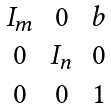Convert formula to latex. <formula><loc_0><loc_0><loc_500><loc_500>\begin{matrix} I _ { m } & 0 & b \\ 0 & I _ { n } & 0 \\ 0 & 0 & 1 \\ \end{matrix}</formula> 